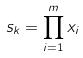<formula> <loc_0><loc_0><loc_500><loc_500>s _ { k } = \prod _ { i = 1 } ^ { m } x _ { i }</formula> 